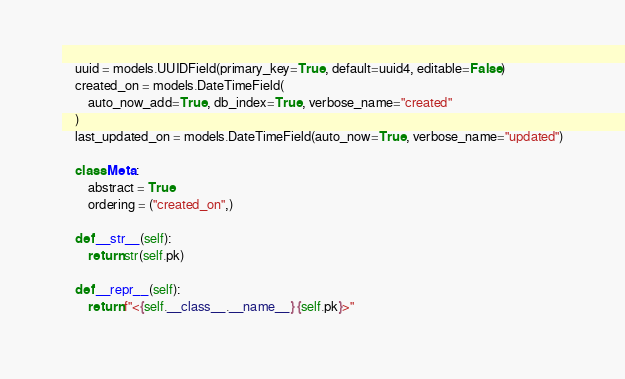<code> <loc_0><loc_0><loc_500><loc_500><_Python_>    uuid = models.UUIDField(primary_key=True, default=uuid4, editable=False)
    created_on = models.DateTimeField(
        auto_now_add=True, db_index=True, verbose_name="created"
    )
    last_updated_on = models.DateTimeField(auto_now=True, verbose_name="updated")

    class Meta:
        abstract = True
        ordering = ("created_on",)

    def __str__(self):
        return str(self.pk)

    def __repr__(self):
        return f"<{self.__class__.__name__} {self.pk}>"
</code> 